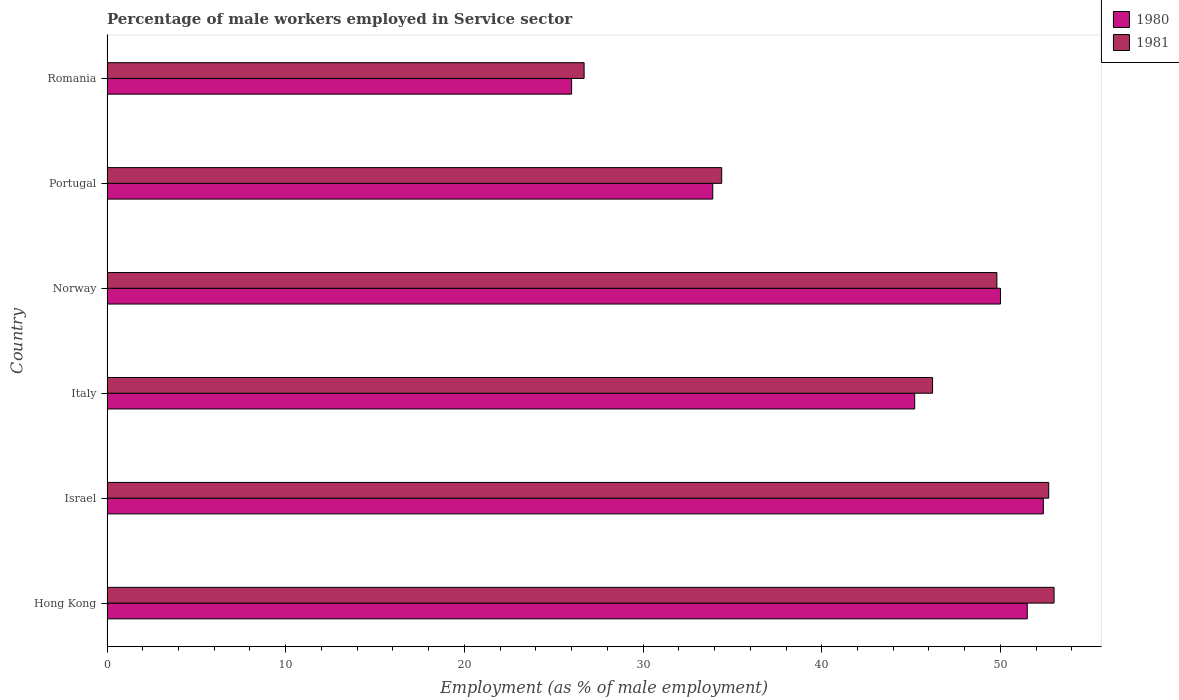How many groups of bars are there?
Your response must be concise. 6. Are the number of bars per tick equal to the number of legend labels?
Your response must be concise. Yes. Are the number of bars on each tick of the Y-axis equal?
Offer a very short reply. Yes. How many bars are there on the 6th tick from the top?
Offer a very short reply. 2. What is the label of the 1st group of bars from the top?
Provide a succinct answer. Romania. What is the percentage of male workers employed in Service sector in 1981 in Italy?
Your response must be concise. 46.2. Across all countries, what is the maximum percentage of male workers employed in Service sector in 1981?
Give a very brief answer. 53. Across all countries, what is the minimum percentage of male workers employed in Service sector in 1981?
Offer a very short reply. 26.7. In which country was the percentage of male workers employed in Service sector in 1981 maximum?
Make the answer very short. Hong Kong. In which country was the percentage of male workers employed in Service sector in 1981 minimum?
Provide a short and direct response. Romania. What is the total percentage of male workers employed in Service sector in 1981 in the graph?
Ensure brevity in your answer.  262.8. What is the difference between the percentage of male workers employed in Service sector in 1981 in Israel and that in Romania?
Your answer should be very brief. 26. What is the difference between the percentage of male workers employed in Service sector in 1980 in Hong Kong and the percentage of male workers employed in Service sector in 1981 in Romania?
Provide a short and direct response. 24.8. What is the average percentage of male workers employed in Service sector in 1980 per country?
Ensure brevity in your answer.  43.17. What is the difference between the percentage of male workers employed in Service sector in 1981 and percentage of male workers employed in Service sector in 1980 in Hong Kong?
Your answer should be very brief. 1.5. What is the ratio of the percentage of male workers employed in Service sector in 1980 in Hong Kong to that in Norway?
Your response must be concise. 1.03. Is the percentage of male workers employed in Service sector in 1980 in Italy less than that in Norway?
Ensure brevity in your answer.  Yes. What is the difference between the highest and the second highest percentage of male workers employed in Service sector in 1980?
Your answer should be compact. 0.9. What is the difference between the highest and the lowest percentage of male workers employed in Service sector in 1981?
Ensure brevity in your answer.  26.3. What does the 1st bar from the top in Portugal represents?
Provide a succinct answer. 1981. What does the 1st bar from the bottom in Norway represents?
Offer a very short reply. 1980. Are all the bars in the graph horizontal?
Provide a succinct answer. Yes. Are the values on the major ticks of X-axis written in scientific E-notation?
Keep it short and to the point. No. Does the graph contain any zero values?
Your response must be concise. No. Where does the legend appear in the graph?
Provide a succinct answer. Top right. How are the legend labels stacked?
Make the answer very short. Vertical. What is the title of the graph?
Offer a very short reply. Percentage of male workers employed in Service sector. Does "1970" appear as one of the legend labels in the graph?
Keep it short and to the point. No. What is the label or title of the X-axis?
Provide a short and direct response. Employment (as % of male employment). What is the label or title of the Y-axis?
Your answer should be compact. Country. What is the Employment (as % of male employment) of 1980 in Hong Kong?
Your answer should be compact. 51.5. What is the Employment (as % of male employment) in 1980 in Israel?
Your answer should be very brief. 52.4. What is the Employment (as % of male employment) of 1981 in Israel?
Make the answer very short. 52.7. What is the Employment (as % of male employment) of 1980 in Italy?
Make the answer very short. 45.2. What is the Employment (as % of male employment) of 1981 in Italy?
Your answer should be compact. 46.2. What is the Employment (as % of male employment) of 1981 in Norway?
Ensure brevity in your answer.  49.8. What is the Employment (as % of male employment) of 1980 in Portugal?
Your answer should be compact. 33.9. What is the Employment (as % of male employment) in 1981 in Portugal?
Your answer should be very brief. 34.4. What is the Employment (as % of male employment) of 1980 in Romania?
Your answer should be compact. 26. What is the Employment (as % of male employment) of 1981 in Romania?
Ensure brevity in your answer.  26.7. Across all countries, what is the maximum Employment (as % of male employment) in 1980?
Your response must be concise. 52.4. Across all countries, what is the minimum Employment (as % of male employment) of 1980?
Provide a succinct answer. 26. Across all countries, what is the minimum Employment (as % of male employment) in 1981?
Ensure brevity in your answer.  26.7. What is the total Employment (as % of male employment) in 1980 in the graph?
Give a very brief answer. 259. What is the total Employment (as % of male employment) of 1981 in the graph?
Your answer should be very brief. 262.8. What is the difference between the Employment (as % of male employment) in 1980 in Hong Kong and that in Israel?
Offer a terse response. -0.9. What is the difference between the Employment (as % of male employment) in 1981 in Hong Kong and that in Italy?
Offer a terse response. 6.8. What is the difference between the Employment (as % of male employment) of 1981 in Hong Kong and that in Norway?
Give a very brief answer. 3.2. What is the difference between the Employment (as % of male employment) of 1980 in Hong Kong and that in Portugal?
Your response must be concise. 17.6. What is the difference between the Employment (as % of male employment) in 1980 in Hong Kong and that in Romania?
Your response must be concise. 25.5. What is the difference between the Employment (as % of male employment) of 1981 in Hong Kong and that in Romania?
Give a very brief answer. 26.3. What is the difference between the Employment (as % of male employment) in 1980 in Israel and that in Norway?
Your answer should be very brief. 2.4. What is the difference between the Employment (as % of male employment) of 1981 in Israel and that in Portugal?
Your answer should be very brief. 18.3. What is the difference between the Employment (as % of male employment) of 1980 in Israel and that in Romania?
Give a very brief answer. 26.4. What is the difference between the Employment (as % of male employment) in 1981 in Italy and that in Norway?
Ensure brevity in your answer.  -3.6. What is the difference between the Employment (as % of male employment) of 1980 in Italy and that in Portugal?
Provide a short and direct response. 11.3. What is the difference between the Employment (as % of male employment) in 1981 in Italy and that in Romania?
Make the answer very short. 19.5. What is the difference between the Employment (as % of male employment) in 1980 in Norway and that in Portugal?
Make the answer very short. 16.1. What is the difference between the Employment (as % of male employment) of 1981 in Norway and that in Romania?
Make the answer very short. 23.1. What is the difference between the Employment (as % of male employment) of 1980 in Portugal and that in Romania?
Keep it short and to the point. 7.9. What is the difference between the Employment (as % of male employment) in 1981 in Portugal and that in Romania?
Keep it short and to the point. 7.7. What is the difference between the Employment (as % of male employment) of 1980 in Hong Kong and the Employment (as % of male employment) of 1981 in Israel?
Your answer should be very brief. -1.2. What is the difference between the Employment (as % of male employment) of 1980 in Hong Kong and the Employment (as % of male employment) of 1981 in Romania?
Provide a succinct answer. 24.8. What is the difference between the Employment (as % of male employment) of 1980 in Israel and the Employment (as % of male employment) of 1981 in Romania?
Provide a succinct answer. 25.7. What is the difference between the Employment (as % of male employment) of 1980 in Norway and the Employment (as % of male employment) of 1981 in Romania?
Your answer should be very brief. 23.3. What is the difference between the Employment (as % of male employment) in 1980 in Portugal and the Employment (as % of male employment) in 1981 in Romania?
Offer a terse response. 7.2. What is the average Employment (as % of male employment) of 1980 per country?
Ensure brevity in your answer.  43.17. What is the average Employment (as % of male employment) of 1981 per country?
Offer a terse response. 43.8. What is the difference between the Employment (as % of male employment) in 1980 and Employment (as % of male employment) in 1981 in Italy?
Keep it short and to the point. -1. What is the difference between the Employment (as % of male employment) in 1980 and Employment (as % of male employment) in 1981 in Portugal?
Offer a terse response. -0.5. What is the difference between the Employment (as % of male employment) in 1980 and Employment (as % of male employment) in 1981 in Romania?
Offer a terse response. -0.7. What is the ratio of the Employment (as % of male employment) in 1980 in Hong Kong to that in Israel?
Ensure brevity in your answer.  0.98. What is the ratio of the Employment (as % of male employment) of 1981 in Hong Kong to that in Israel?
Your answer should be compact. 1.01. What is the ratio of the Employment (as % of male employment) in 1980 in Hong Kong to that in Italy?
Keep it short and to the point. 1.14. What is the ratio of the Employment (as % of male employment) of 1981 in Hong Kong to that in Italy?
Provide a succinct answer. 1.15. What is the ratio of the Employment (as % of male employment) of 1980 in Hong Kong to that in Norway?
Your response must be concise. 1.03. What is the ratio of the Employment (as % of male employment) of 1981 in Hong Kong to that in Norway?
Ensure brevity in your answer.  1.06. What is the ratio of the Employment (as % of male employment) of 1980 in Hong Kong to that in Portugal?
Make the answer very short. 1.52. What is the ratio of the Employment (as % of male employment) of 1981 in Hong Kong to that in Portugal?
Offer a very short reply. 1.54. What is the ratio of the Employment (as % of male employment) in 1980 in Hong Kong to that in Romania?
Make the answer very short. 1.98. What is the ratio of the Employment (as % of male employment) of 1981 in Hong Kong to that in Romania?
Provide a short and direct response. 1.99. What is the ratio of the Employment (as % of male employment) in 1980 in Israel to that in Italy?
Give a very brief answer. 1.16. What is the ratio of the Employment (as % of male employment) in 1981 in Israel to that in Italy?
Keep it short and to the point. 1.14. What is the ratio of the Employment (as % of male employment) in 1980 in Israel to that in Norway?
Provide a succinct answer. 1.05. What is the ratio of the Employment (as % of male employment) in 1981 in Israel to that in Norway?
Your answer should be compact. 1.06. What is the ratio of the Employment (as % of male employment) of 1980 in Israel to that in Portugal?
Give a very brief answer. 1.55. What is the ratio of the Employment (as % of male employment) in 1981 in Israel to that in Portugal?
Your answer should be very brief. 1.53. What is the ratio of the Employment (as % of male employment) in 1980 in Israel to that in Romania?
Ensure brevity in your answer.  2.02. What is the ratio of the Employment (as % of male employment) in 1981 in Israel to that in Romania?
Offer a terse response. 1.97. What is the ratio of the Employment (as % of male employment) of 1980 in Italy to that in Norway?
Provide a short and direct response. 0.9. What is the ratio of the Employment (as % of male employment) in 1981 in Italy to that in Norway?
Offer a terse response. 0.93. What is the ratio of the Employment (as % of male employment) of 1980 in Italy to that in Portugal?
Give a very brief answer. 1.33. What is the ratio of the Employment (as % of male employment) in 1981 in Italy to that in Portugal?
Make the answer very short. 1.34. What is the ratio of the Employment (as % of male employment) of 1980 in Italy to that in Romania?
Ensure brevity in your answer.  1.74. What is the ratio of the Employment (as % of male employment) of 1981 in Italy to that in Romania?
Provide a succinct answer. 1.73. What is the ratio of the Employment (as % of male employment) of 1980 in Norway to that in Portugal?
Your answer should be very brief. 1.47. What is the ratio of the Employment (as % of male employment) in 1981 in Norway to that in Portugal?
Make the answer very short. 1.45. What is the ratio of the Employment (as % of male employment) in 1980 in Norway to that in Romania?
Your answer should be very brief. 1.92. What is the ratio of the Employment (as % of male employment) of 1981 in Norway to that in Romania?
Your answer should be compact. 1.87. What is the ratio of the Employment (as % of male employment) of 1980 in Portugal to that in Romania?
Offer a very short reply. 1.3. What is the ratio of the Employment (as % of male employment) of 1981 in Portugal to that in Romania?
Your answer should be very brief. 1.29. What is the difference between the highest and the second highest Employment (as % of male employment) in 1981?
Provide a succinct answer. 0.3. What is the difference between the highest and the lowest Employment (as % of male employment) in 1980?
Make the answer very short. 26.4. What is the difference between the highest and the lowest Employment (as % of male employment) of 1981?
Ensure brevity in your answer.  26.3. 